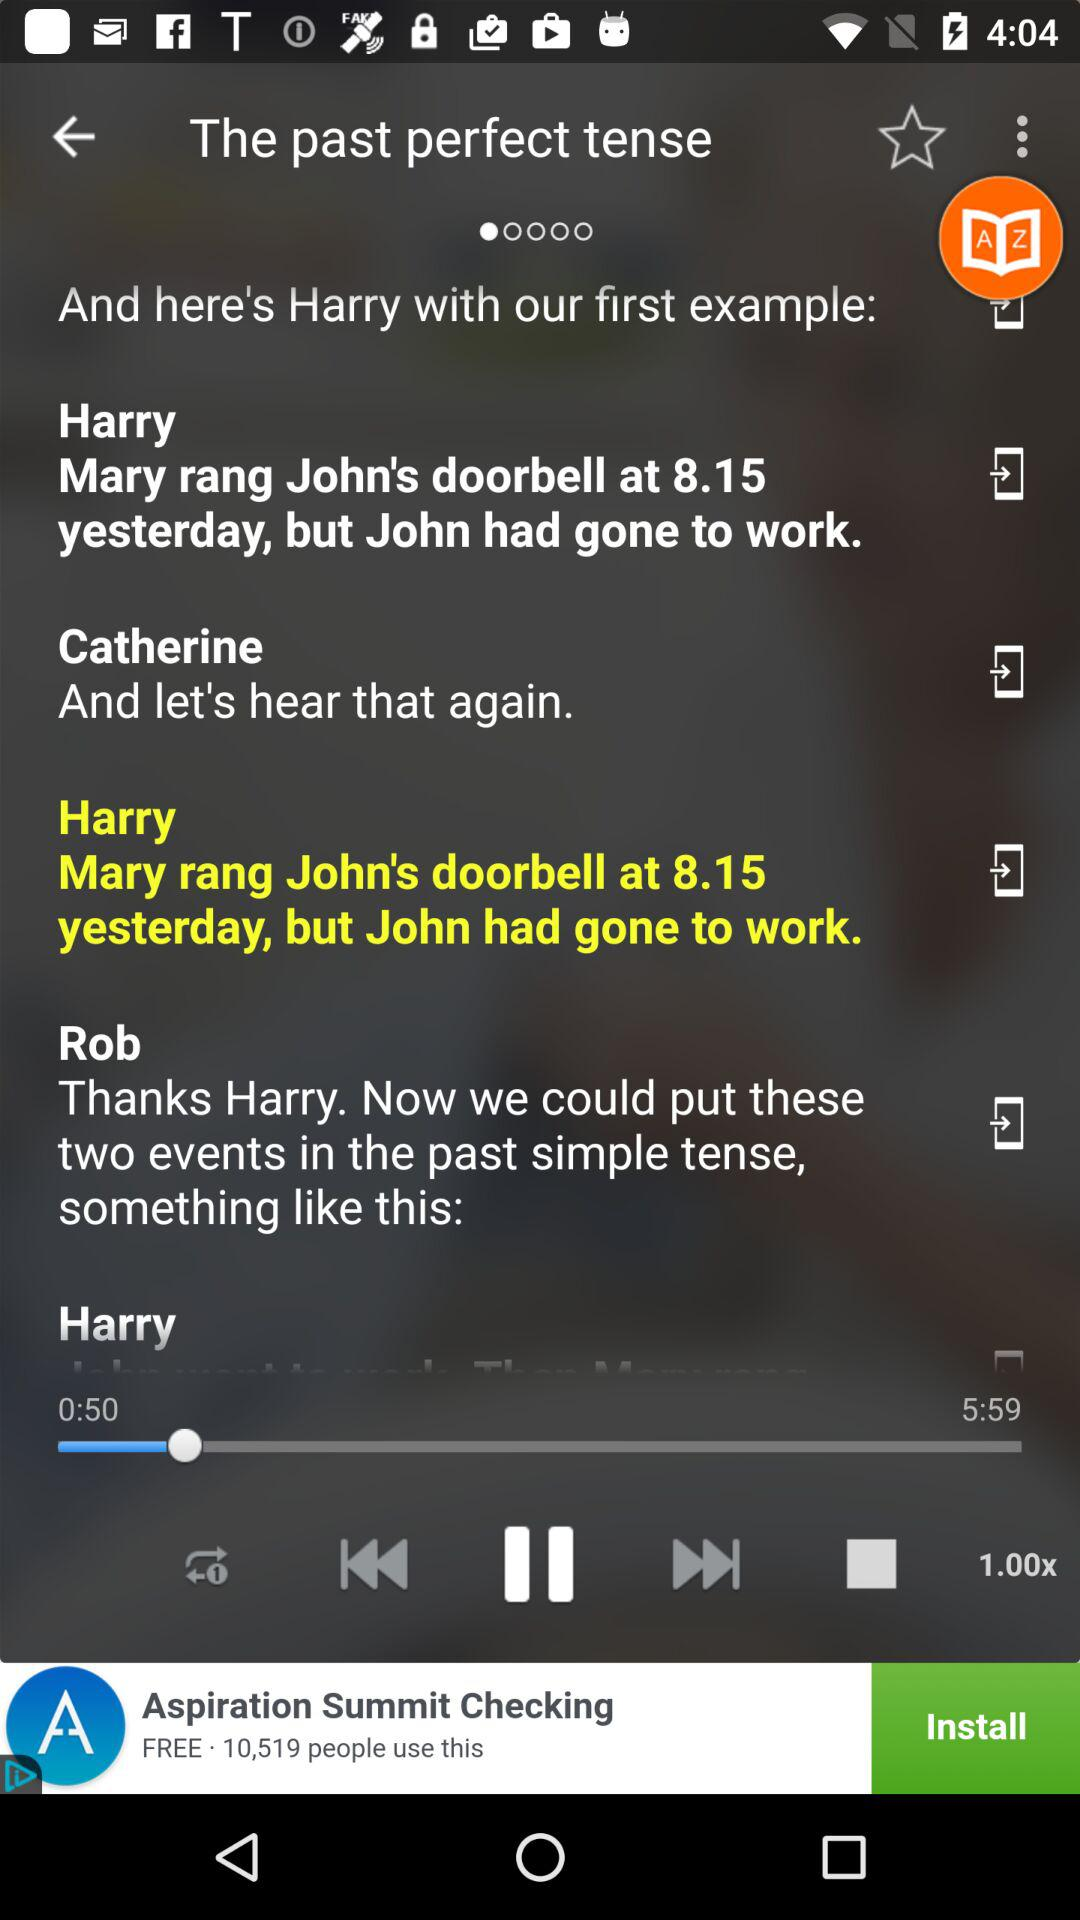How many speakers are there in the video?
Answer the question using a single word or phrase. 3 